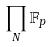Convert formula to latex. <formula><loc_0><loc_0><loc_500><loc_500>\prod _ { N } \mathbb { F } _ { p }</formula> 